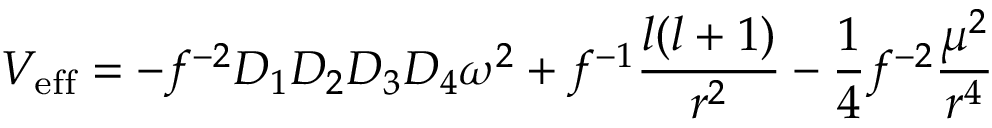<formula> <loc_0><loc_0><loc_500><loc_500>V _ { e f f } = - f ^ { - 2 } D _ { 1 } D _ { 2 } D _ { 3 } D _ { 4 } \omega ^ { 2 } + f ^ { - 1 } { \frac { l ( l + 1 ) } { r ^ { 2 } } } - { \frac { 1 } { 4 } } f ^ { - 2 } { \frac { \mu ^ { 2 } } { r ^ { 4 } } }</formula> 